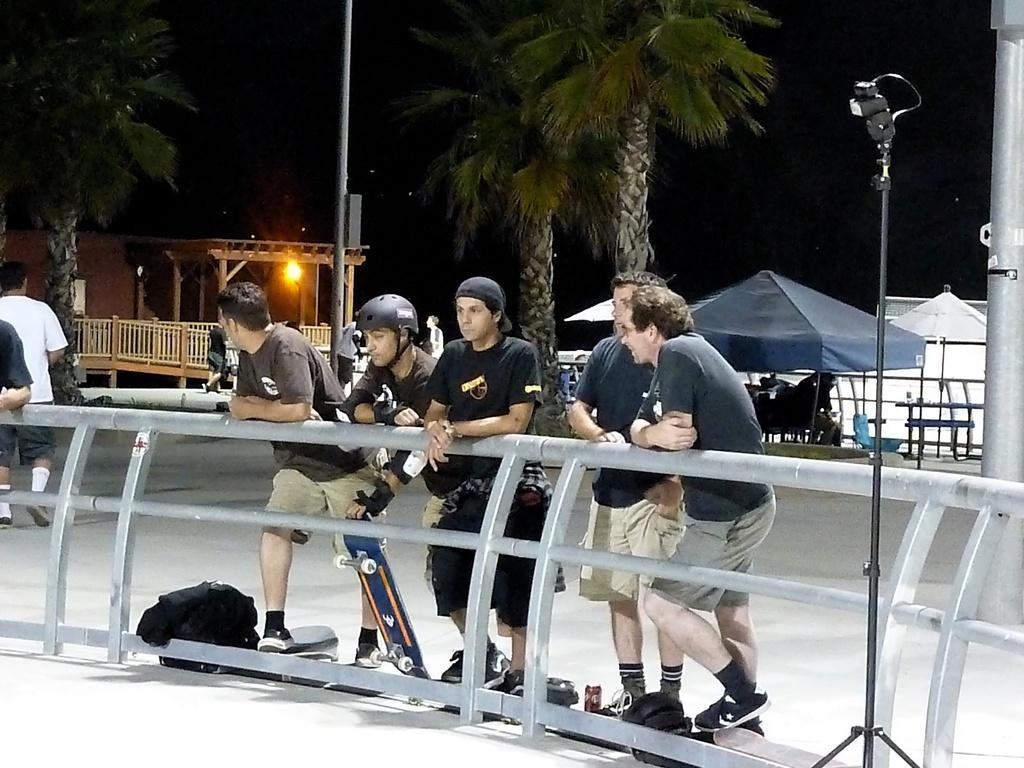Can you describe this image briefly? In this picture there are five persons standing near to the fencing. The second person who is wearing helmet, t-shirt, gloves, short and shoe. He is holding skateboard. On the bottom left there is a black bag near to the fencing. In the background we can see the group of persons sitting on the bench under the umbrella. On the left background there is a house, beside that we can see wooden fencing. On the top we can see street light, pole and trees. On the top left corner we can see stars and darkness. 